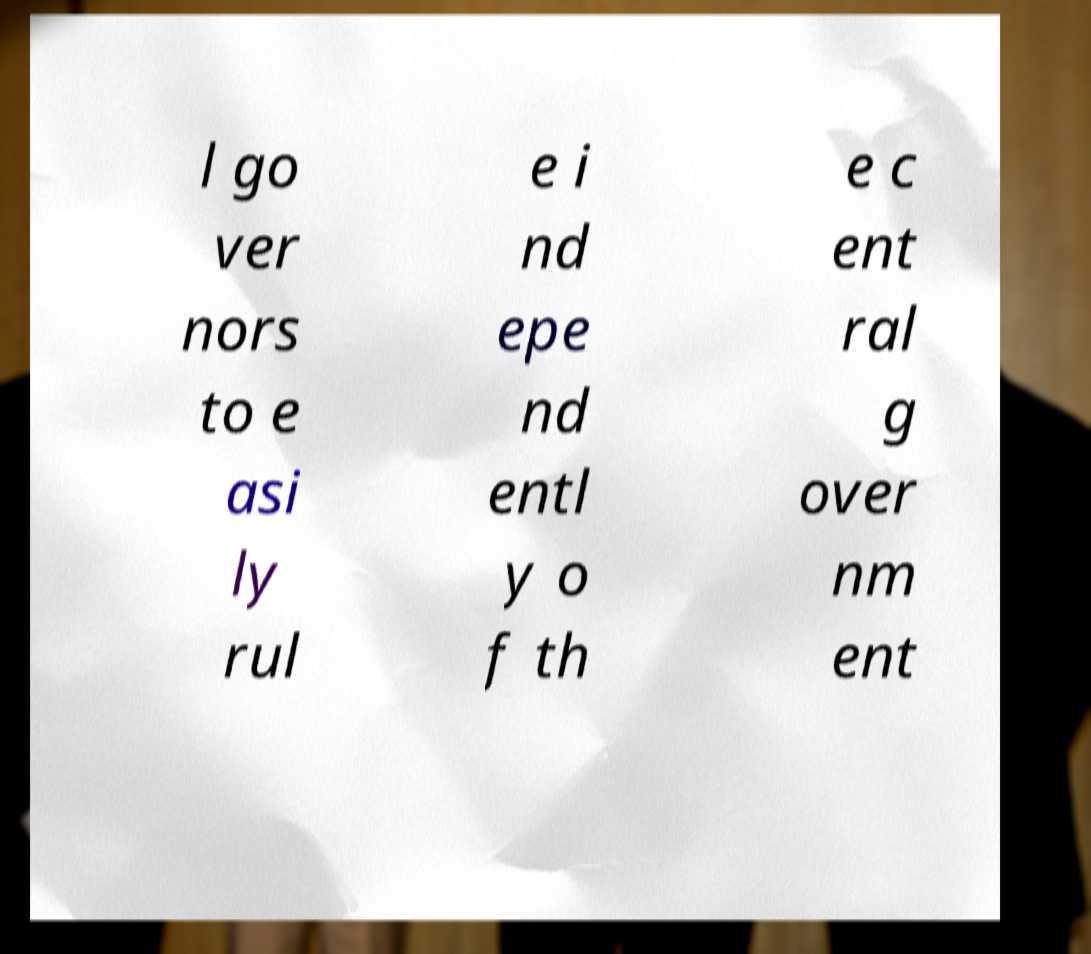Please identify and transcribe the text found in this image. l go ver nors to e asi ly rul e i nd epe nd entl y o f th e c ent ral g over nm ent 